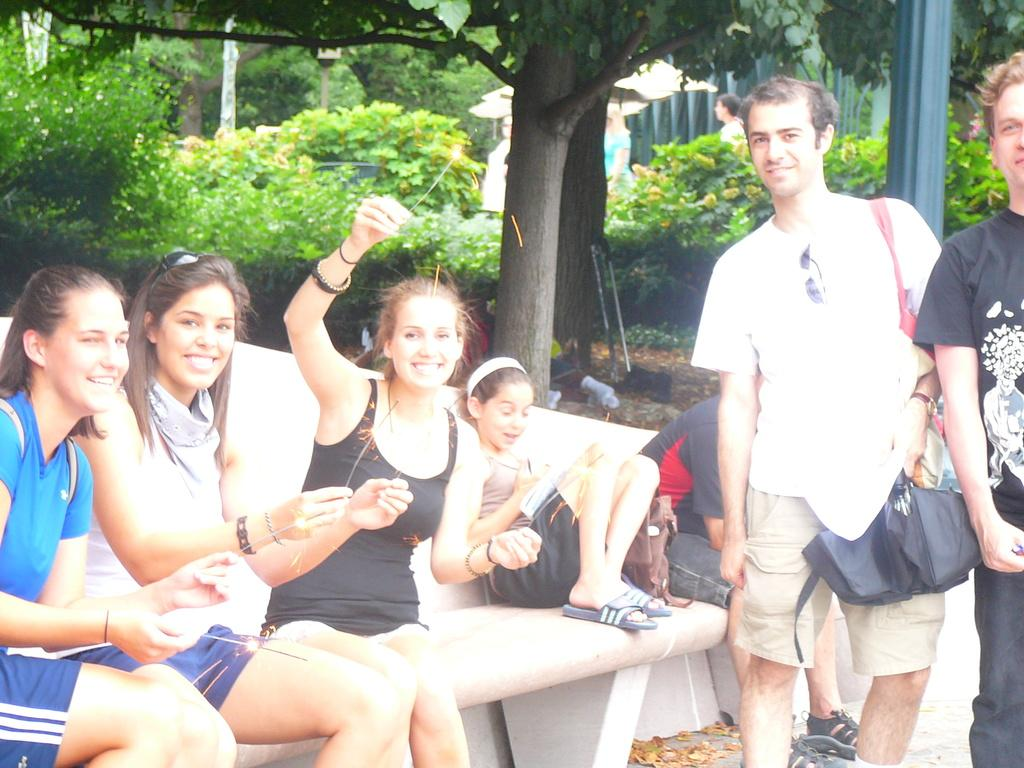What are the people in the image doing? There are people sitting on a bench in the image. Where are the people located in the image? There are people on the right side of the image. What can be seen in the background of the image? There are trees in the background of the image. What else is happening in the background of the image? There are people walking in the background of the image. What type of marble is being used to play a game on the bench? There is no marble or game present on the bench in the image. What kind of shoe is the beggar wearing in the image? There is no beggar or shoe present in the image. 